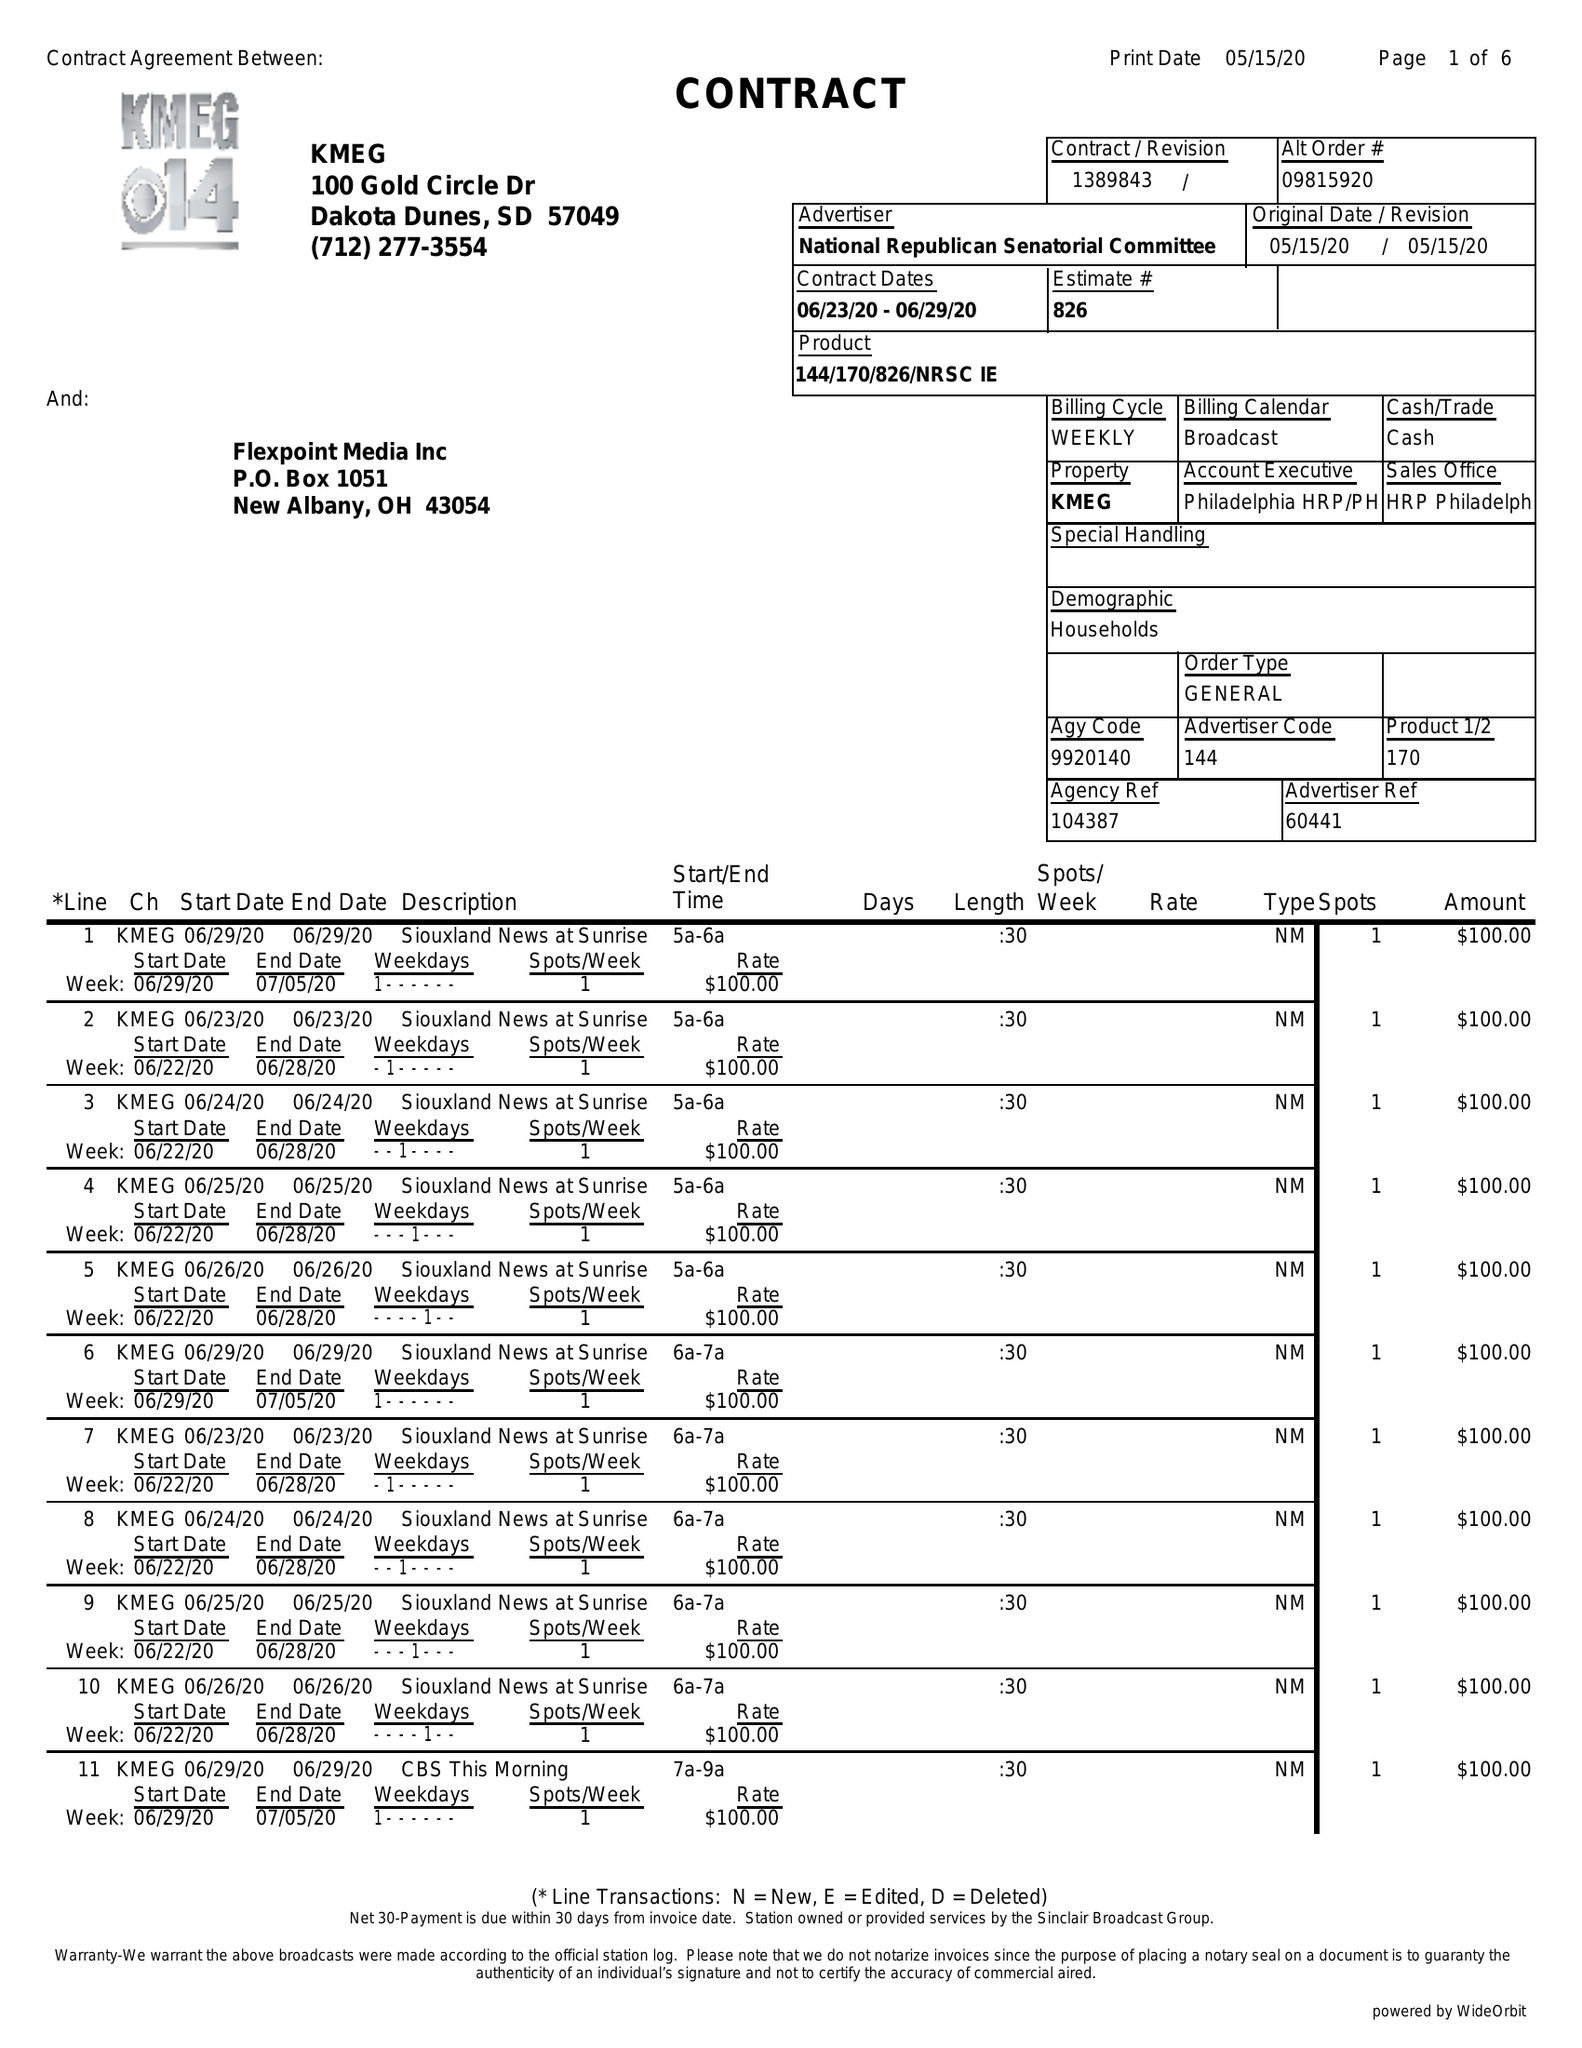What is the value for the flight_to?
Answer the question using a single word or phrase. 06/29/20 